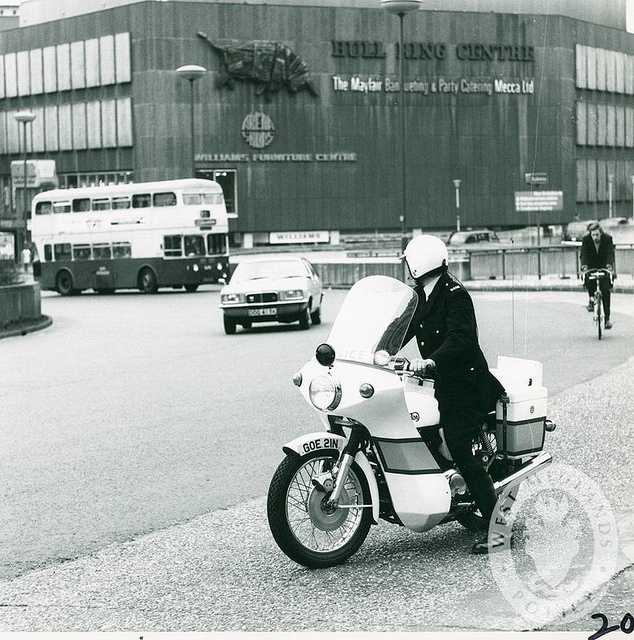<image>What animal is depicted in the photo? I am not sure about the animal in the photo. It can be a dinosaur, armadillo, bird, anteater, or turtle. What animal is depicted in the photo? I am not sure what animal is depicted in the photo. It can be seen dinosaur, armadillo, turtle, bird or anteater. 